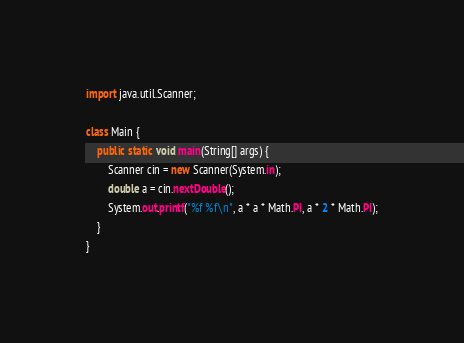Convert code to text. <code><loc_0><loc_0><loc_500><loc_500><_Java_>import java.util.Scanner;

class Main {
	public static void main(String[] args) {
		Scanner cin = new Scanner(System.in);
		double a = cin.nextDouble();
		System.out.printf("%f %f\n", a * a * Math.PI, a * 2 * Math.PI);
	}
}</code> 